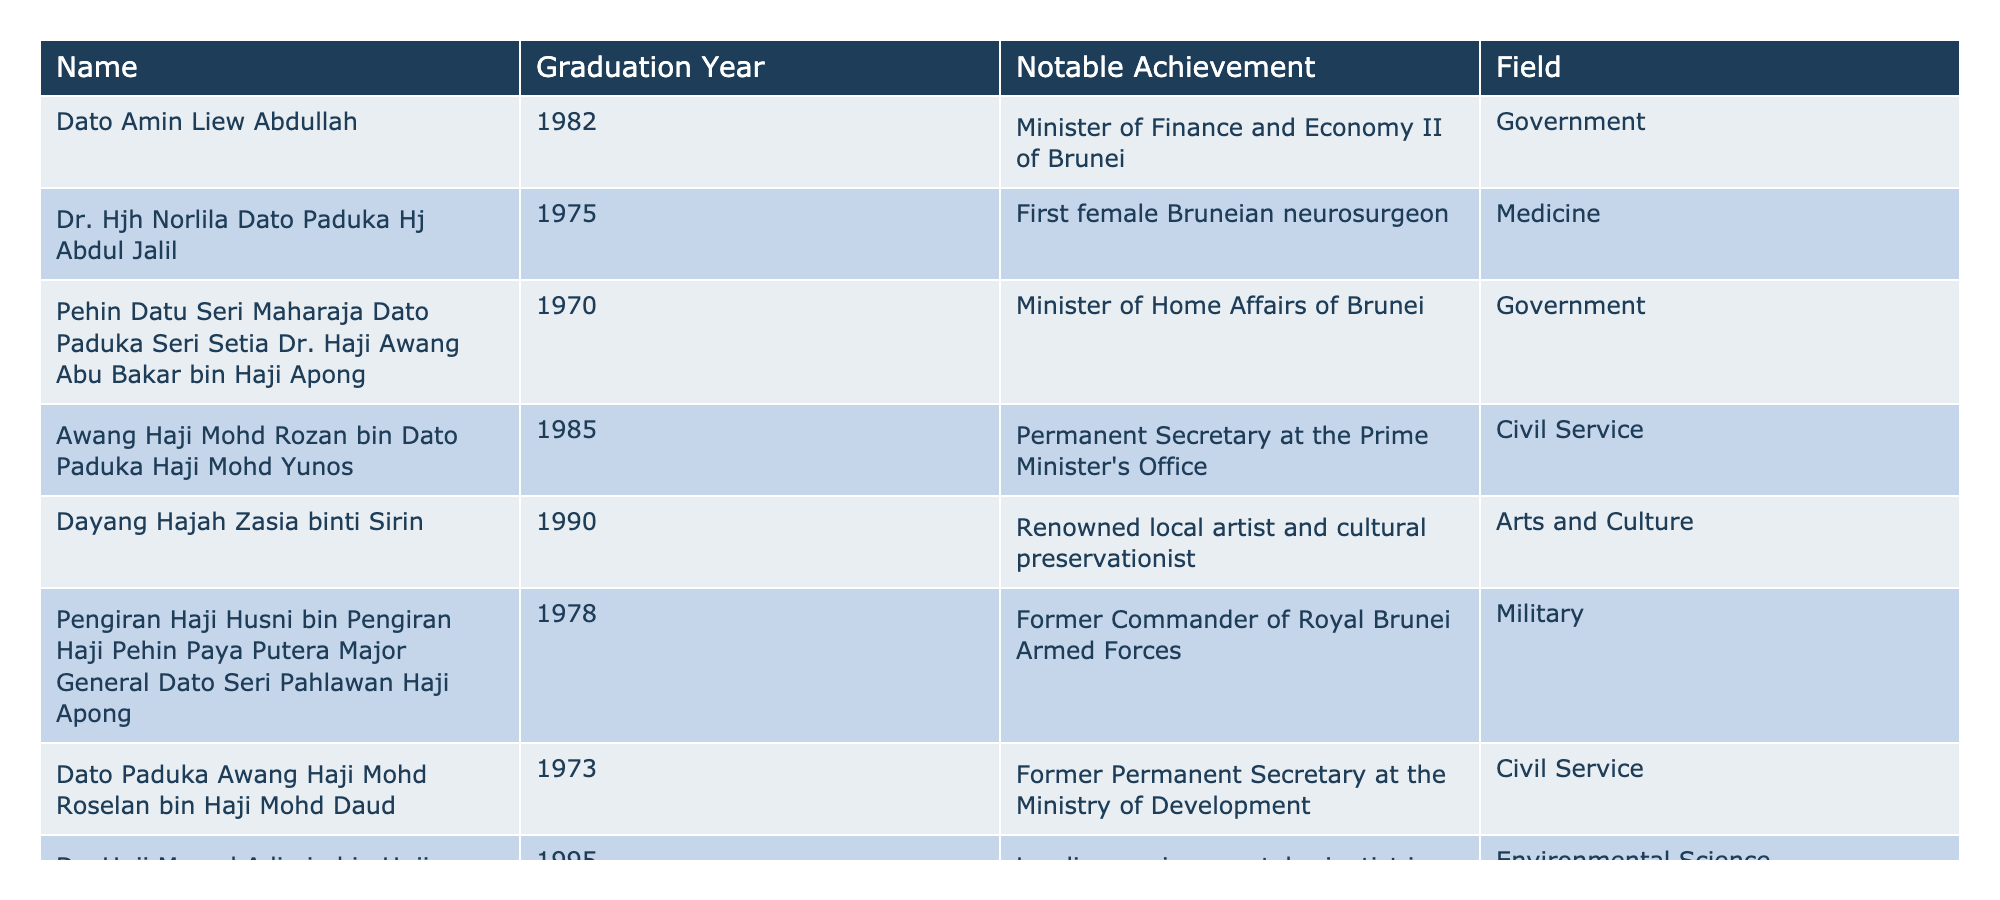What is the graduation year of Dato Amin Liew Abdullah? By looking directly at the table, we see that Dato Amin Liew Abdullah graduated in 1982.
Answer: 1982 Who is the first female Bruneian neurosurgeon? The table lists Dr. Hjh Norlila Dato Paduka Hj Abdul Jalil as the first female Bruneian neurosurgeon.
Answer: Dr. Hjh Norlila Dato Paduka Hj Abdul Jalil Which field does Dayang Hajah Zasia binti Sirin belong to? According to the table, Dayang Hajah Zasia binti Sirin is noted for her contributions in the Arts and Culture field.
Answer: Arts and Culture How many alumni graduated before 1980? The table lists 10 alumni. Out of these, five graduated before 1980 (1970, 1973, 1975, 1978, and 1979).
Answer: 5 Is Awang Haji Mohd Rozan bin Dato Paduka Haji Mohd Yunos associated with the military or civil service? The table lists Awang Haji Mohd Rozan bin Dato Paduka Haji Mohd Yunos as a Permanent Secretary at the Prime Minister's Office, indicating he is associated with civil service, not the military.
Answer: Civil Service Who graduated in 1990 and what is their achievement? The table indicates Dayang Hajah Zasia binti Sirin graduated in 1990 and is a renowned local artist and cultural preservationist.
Answer: Dayang Hajah Zasia binti Sirin, renowned artist Which notable alumnus has the highest achieved position in the government? The table shows Dato Amin Liew Abdullah as the Minister of Finance and Economy II of Brunei, which is a significant government position compared to others listed.
Answer: Dato Amin Liew Abdullah How many alumni have made contributions in the field of Academia? The table shows that only one alumnus, Awang Haji Abdul Aziz bin Haji Hamdan, is noted for his contributions in the field of Academia.
Answer: 1 Is there any alumnus with an environmental science contribution? Yes, the table lists Dr. Haji Mazrul Adimin bin Haji Awang Besar as a leading environmental scientist in Brunei, confirming his contribution to environmental science.
Answer: Yes Which graduation year has the most notable achievements in the field of civil service? The table lists two graduates (Pehin Datu Seri Maharaja Dato Paduka Seri Setia Dr. Haji Awang Abu Bakar bin Haji Apong and Dato Paduka Awang Haji Mohd Roselan bin Haji Mohd Daud) who have made contributions in civil service. Both graduated in 1970 and 1973 respectively.
Answer: 2 